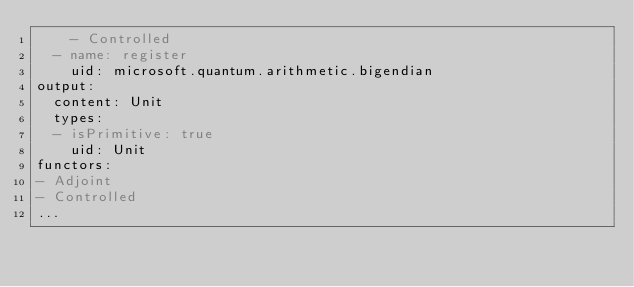Convert code to text. <code><loc_0><loc_0><loc_500><loc_500><_YAML_>    - Controlled
  - name: register
    uid: microsoft.quantum.arithmetic.bigendian
output:
  content: Unit
  types:
  - isPrimitive: true
    uid: Unit
functors:
- Adjoint
- Controlled
...
</code> 